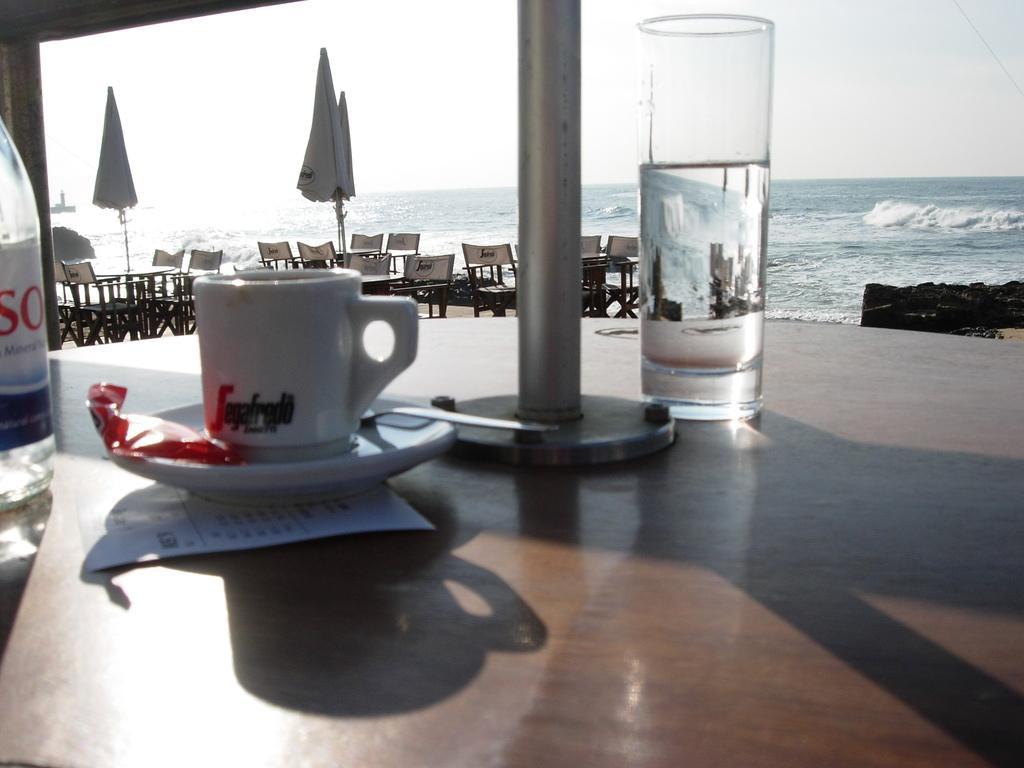Please provide a concise description of this image. This image is taken in outdoors near the sea. In the middle of the image there is a table with glass of water, water bottle, paper, saucer, cup and spoon on it. In the background there are few empty chairs and tables, closed umbrellas and water. 